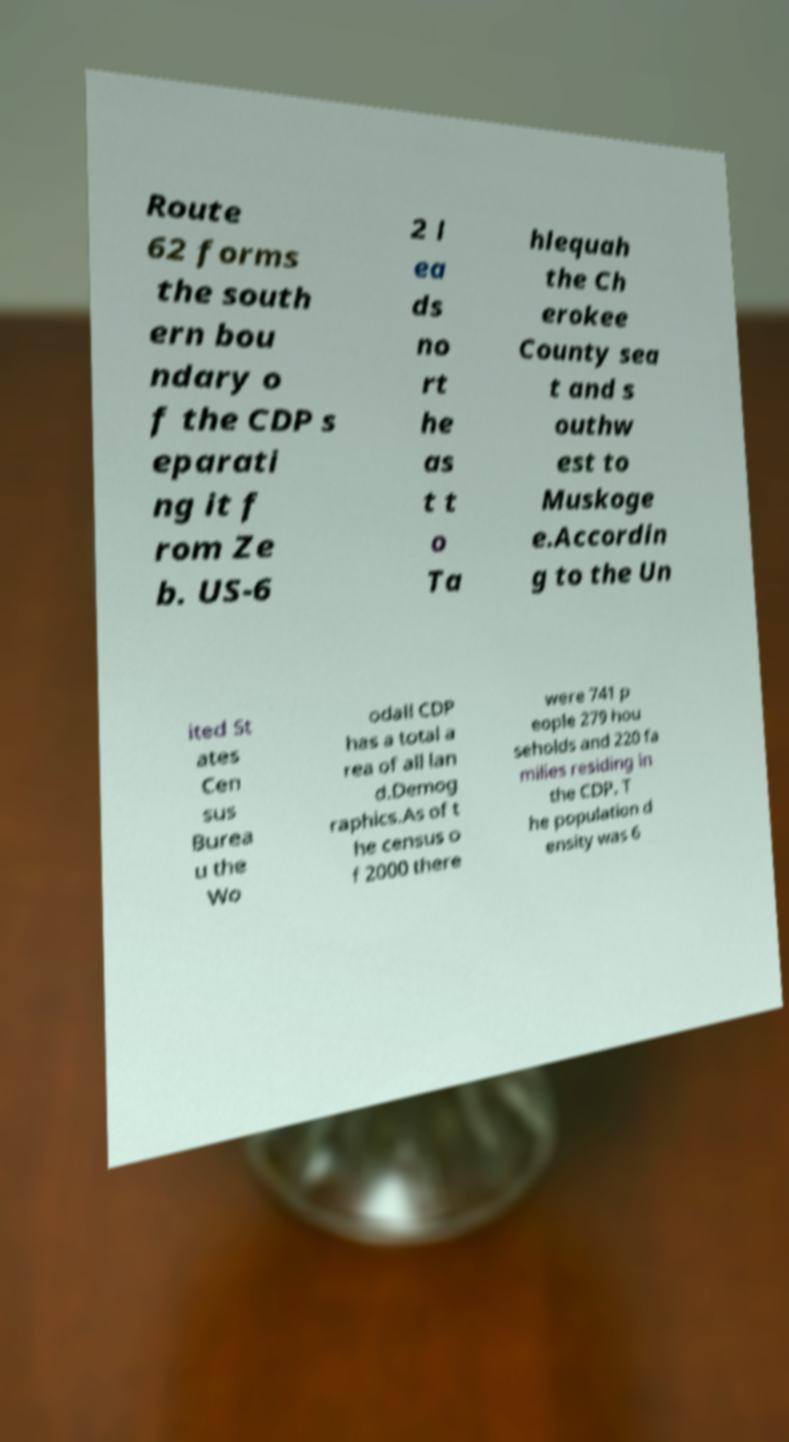I need the written content from this picture converted into text. Can you do that? Route 62 forms the south ern bou ndary o f the CDP s eparati ng it f rom Ze b. US-6 2 l ea ds no rt he as t t o Ta hlequah the Ch erokee County sea t and s outhw est to Muskoge e.Accordin g to the Un ited St ates Cen sus Burea u the Wo odall CDP has a total a rea of all lan d.Demog raphics.As of t he census o f 2000 there were 741 p eople 279 hou seholds and 220 fa milies residing in the CDP. T he population d ensity was 6 